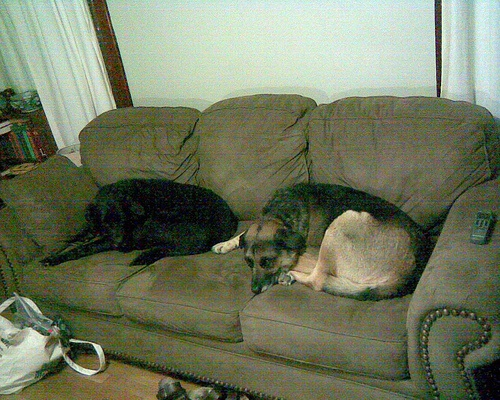Describe the objects in this image and their specific colors. I can see couch in lightgreen, gray, darkgreen, and black tones, dog in lightgreen, black, tan, gray, and darkgreen tones, dog in lightgreen, black, darkgreen, and navy tones, handbag in lightgreen, darkgray, gray, black, and beige tones, and book in lightgreen, black, maroon, olive, and darkgreen tones in this image. 